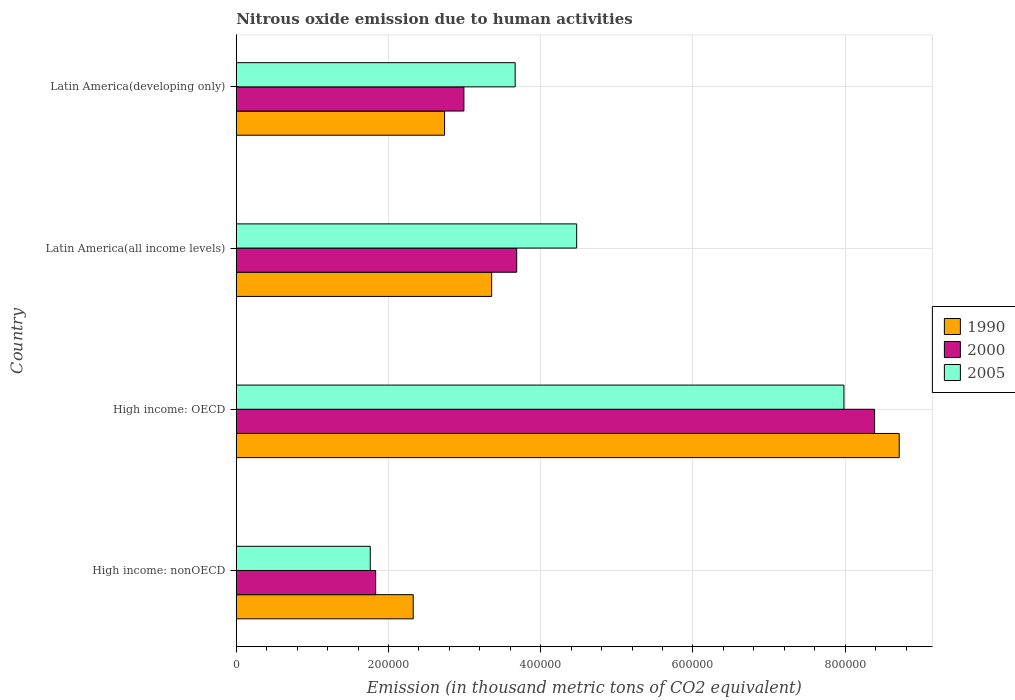How many groups of bars are there?
Your answer should be very brief. 4. Are the number of bars on each tick of the Y-axis equal?
Your answer should be very brief. Yes. What is the label of the 3rd group of bars from the top?
Keep it short and to the point. High income: OECD. In how many cases, is the number of bars for a given country not equal to the number of legend labels?
Offer a very short reply. 0. What is the amount of nitrous oxide emitted in 1990 in High income: OECD?
Keep it short and to the point. 8.71e+05. Across all countries, what is the maximum amount of nitrous oxide emitted in 2005?
Offer a terse response. 7.98e+05. Across all countries, what is the minimum amount of nitrous oxide emitted in 2000?
Ensure brevity in your answer.  1.83e+05. In which country was the amount of nitrous oxide emitted in 1990 maximum?
Give a very brief answer. High income: OECD. In which country was the amount of nitrous oxide emitted in 2005 minimum?
Keep it short and to the point. High income: nonOECD. What is the total amount of nitrous oxide emitted in 2000 in the graph?
Provide a succinct answer. 1.69e+06. What is the difference between the amount of nitrous oxide emitted in 2000 in High income: nonOECD and that in Latin America(all income levels)?
Offer a very short reply. -1.85e+05. What is the difference between the amount of nitrous oxide emitted in 2000 in Latin America(developing only) and the amount of nitrous oxide emitted in 1990 in High income: nonOECD?
Offer a terse response. 6.66e+04. What is the average amount of nitrous oxide emitted in 2000 per country?
Offer a very short reply. 4.22e+05. What is the difference between the amount of nitrous oxide emitted in 2005 and amount of nitrous oxide emitted in 1990 in High income: nonOECD?
Keep it short and to the point. -5.65e+04. In how many countries, is the amount of nitrous oxide emitted in 2005 greater than 600000 thousand metric tons?
Your answer should be very brief. 1. What is the ratio of the amount of nitrous oxide emitted in 2000 in High income: OECD to that in Latin America(developing only)?
Offer a very short reply. 2.8. What is the difference between the highest and the second highest amount of nitrous oxide emitted in 1990?
Provide a short and direct response. 5.35e+05. What is the difference between the highest and the lowest amount of nitrous oxide emitted in 1990?
Provide a succinct answer. 6.38e+05. What does the 3rd bar from the top in Latin America(all income levels) represents?
Make the answer very short. 1990. Is it the case that in every country, the sum of the amount of nitrous oxide emitted in 2000 and amount of nitrous oxide emitted in 1990 is greater than the amount of nitrous oxide emitted in 2005?
Keep it short and to the point. Yes. How many bars are there?
Give a very brief answer. 12. What is the difference between two consecutive major ticks on the X-axis?
Provide a short and direct response. 2.00e+05. Are the values on the major ticks of X-axis written in scientific E-notation?
Keep it short and to the point. No. Where does the legend appear in the graph?
Offer a terse response. Center right. How many legend labels are there?
Give a very brief answer. 3. How are the legend labels stacked?
Keep it short and to the point. Vertical. What is the title of the graph?
Your answer should be very brief. Nitrous oxide emission due to human activities. What is the label or title of the X-axis?
Your response must be concise. Emission (in thousand metric tons of CO2 equivalent). What is the Emission (in thousand metric tons of CO2 equivalent) of 1990 in High income: nonOECD?
Provide a succinct answer. 2.33e+05. What is the Emission (in thousand metric tons of CO2 equivalent) of 2000 in High income: nonOECD?
Provide a succinct answer. 1.83e+05. What is the Emission (in thousand metric tons of CO2 equivalent) in 2005 in High income: nonOECD?
Offer a very short reply. 1.76e+05. What is the Emission (in thousand metric tons of CO2 equivalent) in 1990 in High income: OECD?
Ensure brevity in your answer.  8.71e+05. What is the Emission (in thousand metric tons of CO2 equivalent) in 2000 in High income: OECD?
Offer a terse response. 8.39e+05. What is the Emission (in thousand metric tons of CO2 equivalent) in 2005 in High income: OECD?
Your response must be concise. 7.98e+05. What is the Emission (in thousand metric tons of CO2 equivalent) in 1990 in Latin America(all income levels)?
Your answer should be compact. 3.36e+05. What is the Emission (in thousand metric tons of CO2 equivalent) in 2000 in Latin America(all income levels)?
Your answer should be compact. 3.68e+05. What is the Emission (in thousand metric tons of CO2 equivalent) of 2005 in Latin America(all income levels)?
Make the answer very short. 4.47e+05. What is the Emission (in thousand metric tons of CO2 equivalent) in 1990 in Latin America(developing only)?
Offer a very short reply. 2.74e+05. What is the Emission (in thousand metric tons of CO2 equivalent) in 2000 in Latin America(developing only)?
Provide a short and direct response. 2.99e+05. What is the Emission (in thousand metric tons of CO2 equivalent) of 2005 in Latin America(developing only)?
Your answer should be compact. 3.66e+05. Across all countries, what is the maximum Emission (in thousand metric tons of CO2 equivalent) of 1990?
Make the answer very short. 8.71e+05. Across all countries, what is the maximum Emission (in thousand metric tons of CO2 equivalent) in 2000?
Provide a short and direct response. 8.39e+05. Across all countries, what is the maximum Emission (in thousand metric tons of CO2 equivalent) of 2005?
Your answer should be very brief. 7.98e+05. Across all countries, what is the minimum Emission (in thousand metric tons of CO2 equivalent) in 1990?
Provide a succinct answer. 2.33e+05. Across all countries, what is the minimum Emission (in thousand metric tons of CO2 equivalent) of 2000?
Offer a terse response. 1.83e+05. Across all countries, what is the minimum Emission (in thousand metric tons of CO2 equivalent) of 2005?
Your answer should be very brief. 1.76e+05. What is the total Emission (in thousand metric tons of CO2 equivalent) in 1990 in the graph?
Give a very brief answer. 1.71e+06. What is the total Emission (in thousand metric tons of CO2 equivalent) in 2000 in the graph?
Offer a very short reply. 1.69e+06. What is the total Emission (in thousand metric tons of CO2 equivalent) in 2005 in the graph?
Provide a succinct answer. 1.79e+06. What is the difference between the Emission (in thousand metric tons of CO2 equivalent) in 1990 in High income: nonOECD and that in High income: OECD?
Your answer should be compact. -6.38e+05. What is the difference between the Emission (in thousand metric tons of CO2 equivalent) of 2000 in High income: nonOECD and that in High income: OECD?
Your response must be concise. -6.55e+05. What is the difference between the Emission (in thousand metric tons of CO2 equivalent) in 2005 in High income: nonOECD and that in High income: OECD?
Your response must be concise. -6.22e+05. What is the difference between the Emission (in thousand metric tons of CO2 equivalent) of 1990 in High income: nonOECD and that in Latin America(all income levels)?
Your answer should be very brief. -1.03e+05. What is the difference between the Emission (in thousand metric tons of CO2 equivalent) of 2000 in High income: nonOECD and that in Latin America(all income levels)?
Your answer should be very brief. -1.85e+05. What is the difference between the Emission (in thousand metric tons of CO2 equivalent) of 2005 in High income: nonOECD and that in Latin America(all income levels)?
Offer a terse response. -2.71e+05. What is the difference between the Emission (in thousand metric tons of CO2 equivalent) in 1990 in High income: nonOECD and that in Latin America(developing only)?
Keep it short and to the point. -4.12e+04. What is the difference between the Emission (in thousand metric tons of CO2 equivalent) of 2000 in High income: nonOECD and that in Latin America(developing only)?
Your response must be concise. -1.16e+05. What is the difference between the Emission (in thousand metric tons of CO2 equivalent) in 2005 in High income: nonOECD and that in Latin America(developing only)?
Your answer should be compact. -1.90e+05. What is the difference between the Emission (in thousand metric tons of CO2 equivalent) of 1990 in High income: OECD and that in Latin America(all income levels)?
Your answer should be compact. 5.35e+05. What is the difference between the Emission (in thousand metric tons of CO2 equivalent) of 2000 in High income: OECD and that in Latin America(all income levels)?
Ensure brevity in your answer.  4.70e+05. What is the difference between the Emission (in thousand metric tons of CO2 equivalent) in 2005 in High income: OECD and that in Latin America(all income levels)?
Provide a short and direct response. 3.51e+05. What is the difference between the Emission (in thousand metric tons of CO2 equivalent) in 1990 in High income: OECD and that in Latin America(developing only)?
Provide a succinct answer. 5.97e+05. What is the difference between the Emission (in thousand metric tons of CO2 equivalent) in 2000 in High income: OECD and that in Latin America(developing only)?
Offer a terse response. 5.40e+05. What is the difference between the Emission (in thousand metric tons of CO2 equivalent) of 2005 in High income: OECD and that in Latin America(developing only)?
Give a very brief answer. 4.32e+05. What is the difference between the Emission (in thousand metric tons of CO2 equivalent) in 1990 in Latin America(all income levels) and that in Latin America(developing only)?
Give a very brief answer. 6.18e+04. What is the difference between the Emission (in thousand metric tons of CO2 equivalent) of 2000 in Latin America(all income levels) and that in Latin America(developing only)?
Ensure brevity in your answer.  6.94e+04. What is the difference between the Emission (in thousand metric tons of CO2 equivalent) in 2005 in Latin America(all income levels) and that in Latin America(developing only)?
Offer a very short reply. 8.08e+04. What is the difference between the Emission (in thousand metric tons of CO2 equivalent) in 1990 in High income: nonOECD and the Emission (in thousand metric tons of CO2 equivalent) in 2000 in High income: OECD?
Make the answer very short. -6.06e+05. What is the difference between the Emission (in thousand metric tons of CO2 equivalent) of 1990 in High income: nonOECD and the Emission (in thousand metric tons of CO2 equivalent) of 2005 in High income: OECD?
Your answer should be very brief. -5.66e+05. What is the difference between the Emission (in thousand metric tons of CO2 equivalent) in 2000 in High income: nonOECD and the Emission (in thousand metric tons of CO2 equivalent) in 2005 in High income: OECD?
Provide a succinct answer. -6.15e+05. What is the difference between the Emission (in thousand metric tons of CO2 equivalent) of 1990 in High income: nonOECD and the Emission (in thousand metric tons of CO2 equivalent) of 2000 in Latin America(all income levels)?
Offer a terse response. -1.36e+05. What is the difference between the Emission (in thousand metric tons of CO2 equivalent) of 1990 in High income: nonOECD and the Emission (in thousand metric tons of CO2 equivalent) of 2005 in Latin America(all income levels)?
Give a very brief answer. -2.15e+05. What is the difference between the Emission (in thousand metric tons of CO2 equivalent) in 2000 in High income: nonOECD and the Emission (in thousand metric tons of CO2 equivalent) in 2005 in Latin America(all income levels)?
Your answer should be very brief. -2.64e+05. What is the difference between the Emission (in thousand metric tons of CO2 equivalent) in 1990 in High income: nonOECD and the Emission (in thousand metric tons of CO2 equivalent) in 2000 in Latin America(developing only)?
Ensure brevity in your answer.  -6.66e+04. What is the difference between the Emission (in thousand metric tons of CO2 equivalent) in 1990 in High income: nonOECD and the Emission (in thousand metric tons of CO2 equivalent) in 2005 in Latin America(developing only)?
Keep it short and to the point. -1.34e+05. What is the difference between the Emission (in thousand metric tons of CO2 equivalent) of 2000 in High income: nonOECD and the Emission (in thousand metric tons of CO2 equivalent) of 2005 in Latin America(developing only)?
Your response must be concise. -1.83e+05. What is the difference between the Emission (in thousand metric tons of CO2 equivalent) in 1990 in High income: OECD and the Emission (in thousand metric tons of CO2 equivalent) in 2000 in Latin America(all income levels)?
Make the answer very short. 5.03e+05. What is the difference between the Emission (in thousand metric tons of CO2 equivalent) of 1990 in High income: OECD and the Emission (in thousand metric tons of CO2 equivalent) of 2005 in Latin America(all income levels)?
Your answer should be very brief. 4.24e+05. What is the difference between the Emission (in thousand metric tons of CO2 equivalent) of 2000 in High income: OECD and the Emission (in thousand metric tons of CO2 equivalent) of 2005 in Latin America(all income levels)?
Offer a terse response. 3.91e+05. What is the difference between the Emission (in thousand metric tons of CO2 equivalent) of 1990 in High income: OECD and the Emission (in thousand metric tons of CO2 equivalent) of 2000 in Latin America(developing only)?
Your answer should be very brief. 5.72e+05. What is the difference between the Emission (in thousand metric tons of CO2 equivalent) of 1990 in High income: OECD and the Emission (in thousand metric tons of CO2 equivalent) of 2005 in Latin America(developing only)?
Your response must be concise. 5.05e+05. What is the difference between the Emission (in thousand metric tons of CO2 equivalent) of 2000 in High income: OECD and the Emission (in thousand metric tons of CO2 equivalent) of 2005 in Latin America(developing only)?
Offer a very short reply. 4.72e+05. What is the difference between the Emission (in thousand metric tons of CO2 equivalent) of 1990 in Latin America(all income levels) and the Emission (in thousand metric tons of CO2 equivalent) of 2000 in Latin America(developing only)?
Keep it short and to the point. 3.65e+04. What is the difference between the Emission (in thousand metric tons of CO2 equivalent) in 1990 in Latin America(all income levels) and the Emission (in thousand metric tons of CO2 equivalent) in 2005 in Latin America(developing only)?
Offer a terse response. -3.09e+04. What is the difference between the Emission (in thousand metric tons of CO2 equivalent) of 2000 in Latin America(all income levels) and the Emission (in thousand metric tons of CO2 equivalent) of 2005 in Latin America(developing only)?
Your response must be concise. 2012. What is the average Emission (in thousand metric tons of CO2 equivalent) of 1990 per country?
Your answer should be very brief. 4.28e+05. What is the average Emission (in thousand metric tons of CO2 equivalent) in 2000 per country?
Make the answer very short. 4.22e+05. What is the average Emission (in thousand metric tons of CO2 equivalent) of 2005 per country?
Offer a very short reply. 4.47e+05. What is the difference between the Emission (in thousand metric tons of CO2 equivalent) of 1990 and Emission (in thousand metric tons of CO2 equivalent) of 2000 in High income: nonOECD?
Offer a terse response. 4.94e+04. What is the difference between the Emission (in thousand metric tons of CO2 equivalent) in 1990 and Emission (in thousand metric tons of CO2 equivalent) in 2005 in High income: nonOECD?
Your answer should be very brief. 5.65e+04. What is the difference between the Emission (in thousand metric tons of CO2 equivalent) in 2000 and Emission (in thousand metric tons of CO2 equivalent) in 2005 in High income: nonOECD?
Offer a very short reply. 7109.4. What is the difference between the Emission (in thousand metric tons of CO2 equivalent) of 1990 and Emission (in thousand metric tons of CO2 equivalent) of 2000 in High income: OECD?
Your answer should be compact. 3.24e+04. What is the difference between the Emission (in thousand metric tons of CO2 equivalent) in 1990 and Emission (in thousand metric tons of CO2 equivalent) in 2005 in High income: OECD?
Your answer should be compact. 7.26e+04. What is the difference between the Emission (in thousand metric tons of CO2 equivalent) of 2000 and Emission (in thousand metric tons of CO2 equivalent) of 2005 in High income: OECD?
Give a very brief answer. 4.02e+04. What is the difference between the Emission (in thousand metric tons of CO2 equivalent) in 1990 and Emission (in thousand metric tons of CO2 equivalent) in 2000 in Latin America(all income levels)?
Keep it short and to the point. -3.29e+04. What is the difference between the Emission (in thousand metric tons of CO2 equivalent) of 1990 and Emission (in thousand metric tons of CO2 equivalent) of 2005 in Latin America(all income levels)?
Provide a short and direct response. -1.12e+05. What is the difference between the Emission (in thousand metric tons of CO2 equivalent) of 2000 and Emission (in thousand metric tons of CO2 equivalent) of 2005 in Latin America(all income levels)?
Make the answer very short. -7.88e+04. What is the difference between the Emission (in thousand metric tons of CO2 equivalent) of 1990 and Emission (in thousand metric tons of CO2 equivalent) of 2000 in Latin America(developing only)?
Your answer should be very brief. -2.54e+04. What is the difference between the Emission (in thousand metric tons of CO2 equivalent) in 1990 and Emission (in thousand metric tons of CO2 equivalent) in 2005 in Latin America(developing only)?
Your answer should be very brief. -9.27e+04. What is the difference between the Emission (in thousand metric tons of CO2 equivalent) in 2000 and Emission (in thousand metric tons of CO2 equivalent) in 2005 in Latin America(developing only)?
Make the answer very short. -6.74e+04. What is the ratio of the Emission (in thousand metric tons of CO2 equivalent) in 1990 in High income: nonOECD to that in High income: OECD?
Offer a terse response. 0.27. What is the ratio of the Emission (in thousand metric tons of CO2 equivalent) in 2000 in High income: nonOECD to that in High income: OECD?
Offer a very short reply. 0.22. What is the ratio of the Emission (in thousand metric tons of CO2 equivalent) in 2005 in High income: nonOECD to that in High income: OECD?
Ensure brevity in your answer.  0.22. What is the ratio of the Emission (in thousand metric tons of CO2 equivalent) in 1990 in High income: nonOECD to that in Latin America(all income levels)?
Your response must be concise. 0.69. What is the ratio of the Emission (in thousand metric tons of CO2 equivalent) of 2000 in High income: nonOECD to that in Latin America(all income levels)?
Offer a terse response. 0.5. What is the ratio of the Emission (in thousand metric tons of CO2 equivalent) of 2005 in High income: nonOECD to that in Latin America(all income levels)?
Provide a succinct answer. 0.39. What is the ratio of the Emission (in thousand metric tons of CO2 equivalent) of 1990 in High income: nonOECD to that in Latin America(developing only)?
Make the answer very short. 0.85. What is the ratio of the Emission (in thousand metric tons of CO2 equivalent) in 2000 in High income: nonOECD to that in Latin America(developing only)?
Provide a short and direct response. 0.61. What is the ratio of the Emission (in thousand metric tons of CO2 equivalent) in 2005 in High income: nonOECD to that in Latin America(developing only)?
Give a very brief answer. 0.48. What is the ratio of the Emission (in thousand metric tons of CO2 equivalent) in 1990 in High income: OECD to that in Latin America(all income levels)?
Keep it short and to the point. 2.6. What is the ratio of the Emission (in thousand metric tons of CO2 equivalent) in 2000 in High income: OECD to that in Latin America(all income levels)?
Give a very brief answer. 2.28. What is the ratio of the Emission (in thousand metric tons of CO2 equivalent) of 2005 in High income: OECD to that in Latin America(all income levels)?
Your response must be concise. 1.78. What is the ratio of the Emission (in thousand metric tons of CO2 equivalent) in 1990 in High income: OECD to that in Latin America(developing only)?
Give a very brief answer. 3.18. What is the ratio of the Emission (in thousand metric tons of CO2 equivalent) of 2000 in High income: OECD to that in Latin America(developing only)?
Offer a very short reply. 2.8. What is the ratio of the Emission (in thousand metric tons of CO2 equivalent) in 2005 in High income: OECD to that in Latin America(developing only)?
Offer a very short reply. 2.18. What is the ratio of the Emission (in thousand metric tons of CO2 equivalent) in 1990 in Latin America(all income levels) to that in Latin America(developing only)?
Your response must be concise. 1.23. What is the ratio of the Emission (in thousand metric tons of CO2 equivalent) in 2000 in Latin America(all income levels) to that in Latin America(developing only)?
Provide a succinct answer. 1.23. What is the ratio of the Emission (in thousand metric tons of CO2 equivalent) of 2005 in Latin America(all income levels) to that in Latin America(developing only)?
Your response must be concise. 1.22. What is the difference between the highest and the second highest Emission (in thousand metric tons of CO2 equivalent) in 1990?
Your answer should be very brief. 5.35e+05. What is the difference between the highest and the second highest Emission (in thousand metric tons of CO2 equivalent) of 2000?
Provide a succinct answer. 4.70e+05. What is the difference between the highest and the second highest Emission (in thousand metric tons of CO2 equivalent) of 2005?
Your response must be concise. 3.51e+05. What is the difference between the highest and the lowest Emission (in thousand metric tons of CO2 equivalent) in 1990?
Give a very brief answer. 6.38e+05. What is the difference between the highest and the lowest Emission (in thousand metric tons of CO2 equivalent) of 2000?
Provide a short and direct response. 6.55e+05. What is the difference between the highest and the lowest Emission (in thousand metric tons of CO2 equivalent) in 2005?
Your answer should be compact. 6.22e+05. 